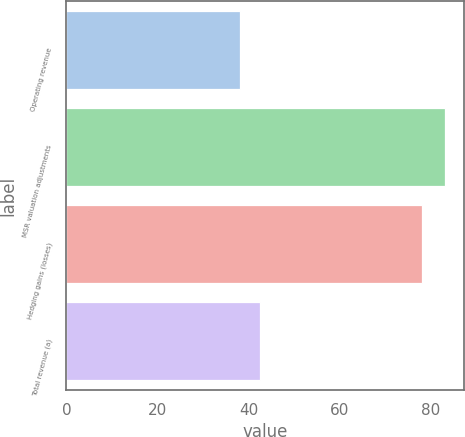Convert chart to OTSL. <chart><loc_0><loc_0><loc_500><loc_500><bar_chart><fcel>Operating revenue<fcel>MSR valuation adjustments<fcel>Hedging gains (losses)<fcel>Total revenue (a)<nl><fcel>38<fcel>83<fcel>78<fcel>42.5<nl></chart> 